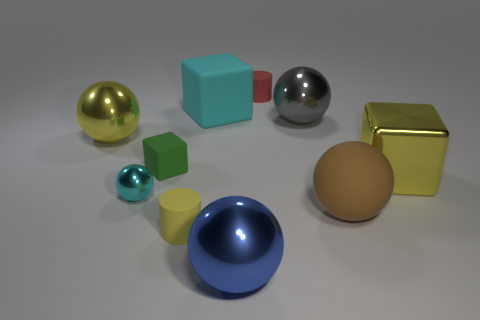What could be the context or use for these objects? These objects could be part of a 3D modeling software tutorial, illustrating how different geometrical shapes can be rendered with various colors and materials. They might also be used in a physics simulation to demonstrate concepts of light and reflections. 